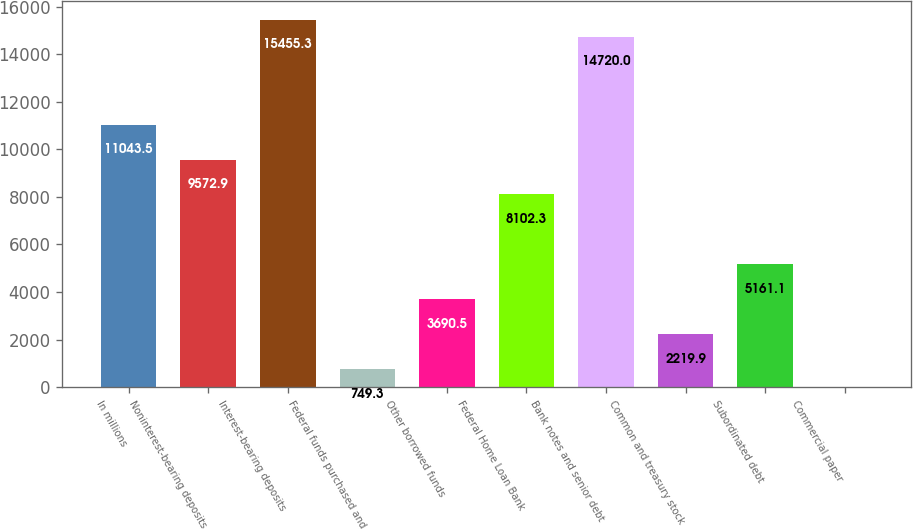Convert chart to OTSL. <chart><loc_0><loc_0><loc_500><loc_500><bar_chart><fcel>In millions<fcel>Noninterest-bearing deposits<fcel>Interest-bearing deposits<fcel>Federal funds purchased and<fcel>Other borrowed funds<fcel>Federal Home Loan Bank<fcel>Bank notes and senior debt<fcel>Common and treasury stock<fcel>Subordinated debt<fcel>Commercial paper<nl><fcel>11043.5<fcel>9572.9<fcel>15455.3<fcel>749.3<fcel>3690.5<fcel>8102.3<fcel>14720<fcel>2219.9<fcel>5161.1<fcel>14<nl></chart> 